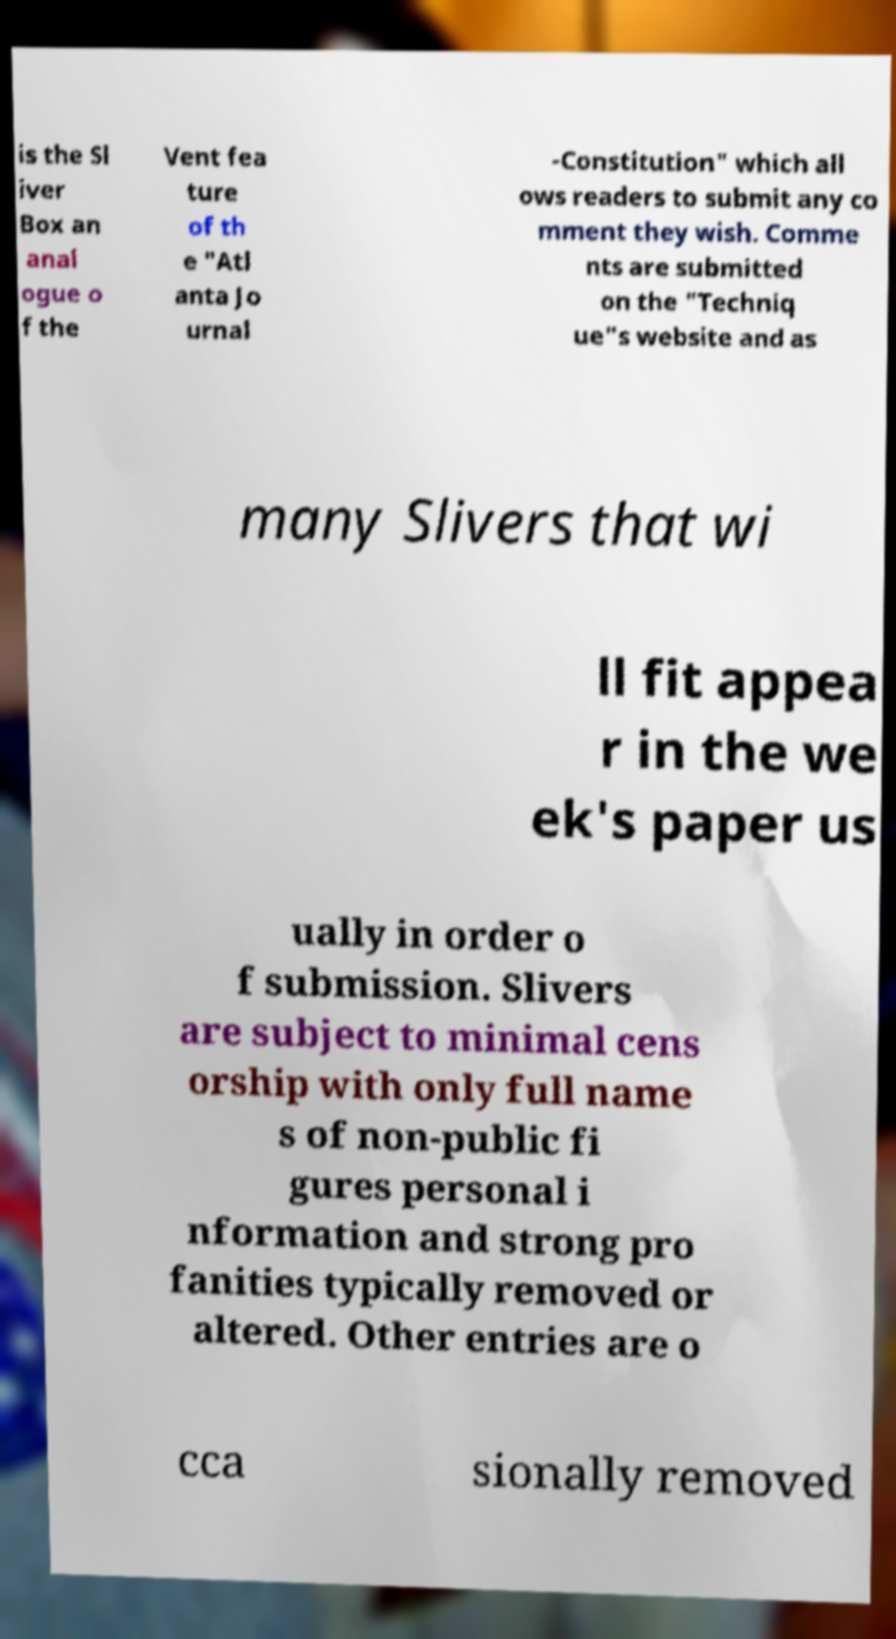There's text embedded in this image that I need extracted. Can you transcribe it verbatim? is the Sl iver Box an anal ogue o f the Vent fea ture of th e "Atl anta Jo urnal -Constitution" which all ows readers to submit any co mment they wish. Comme nts are submitted on the "Techniq ue"s website and as many Slivers that wi ll fit appea r in the we ek's paper us ually in order o f submission. Slivers are subject to minimal cens orship with only full name s of non-public fi gures personal i nformation and strong pro fanities typically removed or altered. Other entries are o cca sionally removed 